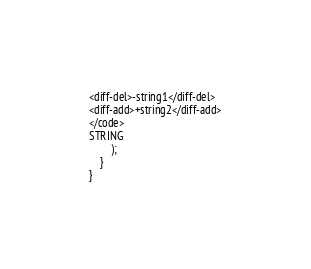<code> <loc_0><loc_0><loc_500><loc_500><_PHP_><diff-del>-string1</diff-del>
<diff-add>+string2</diff-add>
</code>
STRING
        );
    }
}
</code> 